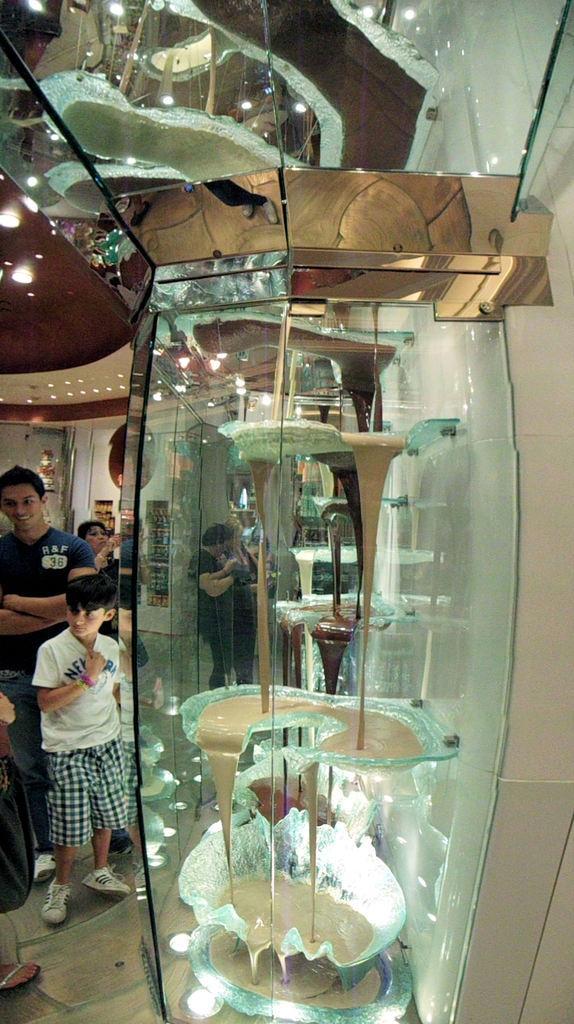Could you give a brief overview of what you see in this image? This image is clicked inside a room. There is glass in the middle. There are persons on the left side. There are lights at the top. 